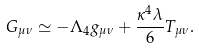<formula> <loc_0><loc_0><loc_500><loc_500>G _ { \mu \nu } \simeq - \Lambda _ { 4 } g _ { \mu \nu } + \frac { \kappa ^ { 4 } \lambda } { 6 } T _ { \mu \nu } .</formula> 